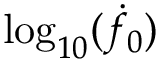Convert formula to latex. <formula><loc_0><loc_0><loc_500><loc_500>\log _ { 1 0 } ( \dot { f } _ { 0 } )</formula> 